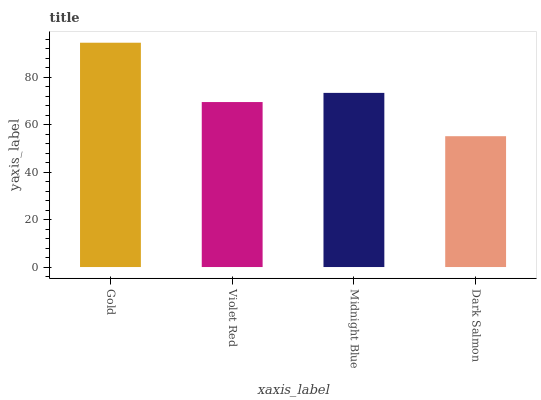Is Violet Red the minimum?
Answer yes or no. No. Is Violet Red the maximum?
Answer yes or no. No. Is Gold greater than Violet Red?
Answer yes or no. Yes. Is Violet Red less than Gold?
Answer yes or no. Yes. Is Violet Red greater than Gold?
Answer yes or no. No. Is Gold less than Violet Red?
Answer yes or no. No. Is Midnight Blue the high median?
Answer yes or no. Yes. Is Violet Red the low median?
Answer yes or no. Yes. Is Gold the high median?
Answer yes or no. No. Is Midnight Blue the low median?
Answer yes or no. No. 